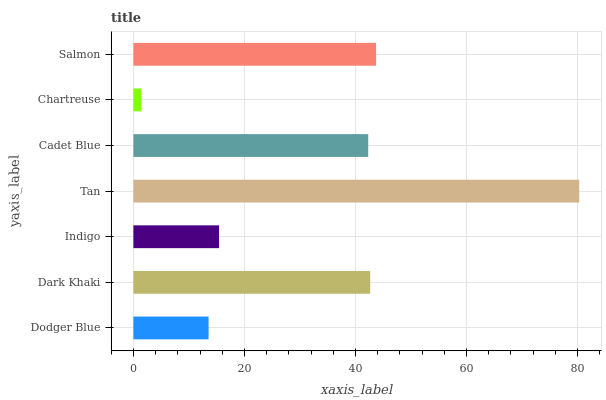Is Chartreuse the minimum?
Answer yes or no. Yes. Is Tan the maximum?
Answer yes or no. Yes. Is Dark Khaki the minimum?
Answer yes or no. No. Is Dark Khaki the maximum?
Answer yes or no. No. Is Dark Khaki greater than Dodger Blue?
Answer yes or no. Yes. Is Dodger Blue less than Dark Khaki?
Answer yes or no. Yes. Is Dodger Blue greater than Dark Khaki?
Answer yes or no. No. Is Dark Khaki less than Dodger Blue?
Answer yes or no. No. Is Cadet Blue the high median?
Answer yes or no. Yes. Is Cadet Blue the low median?
Answer yes or no. Yes. Is Salmon the high median?
Answer yes or no. No. Is Tan the low median?
Answer yes or no. No. 